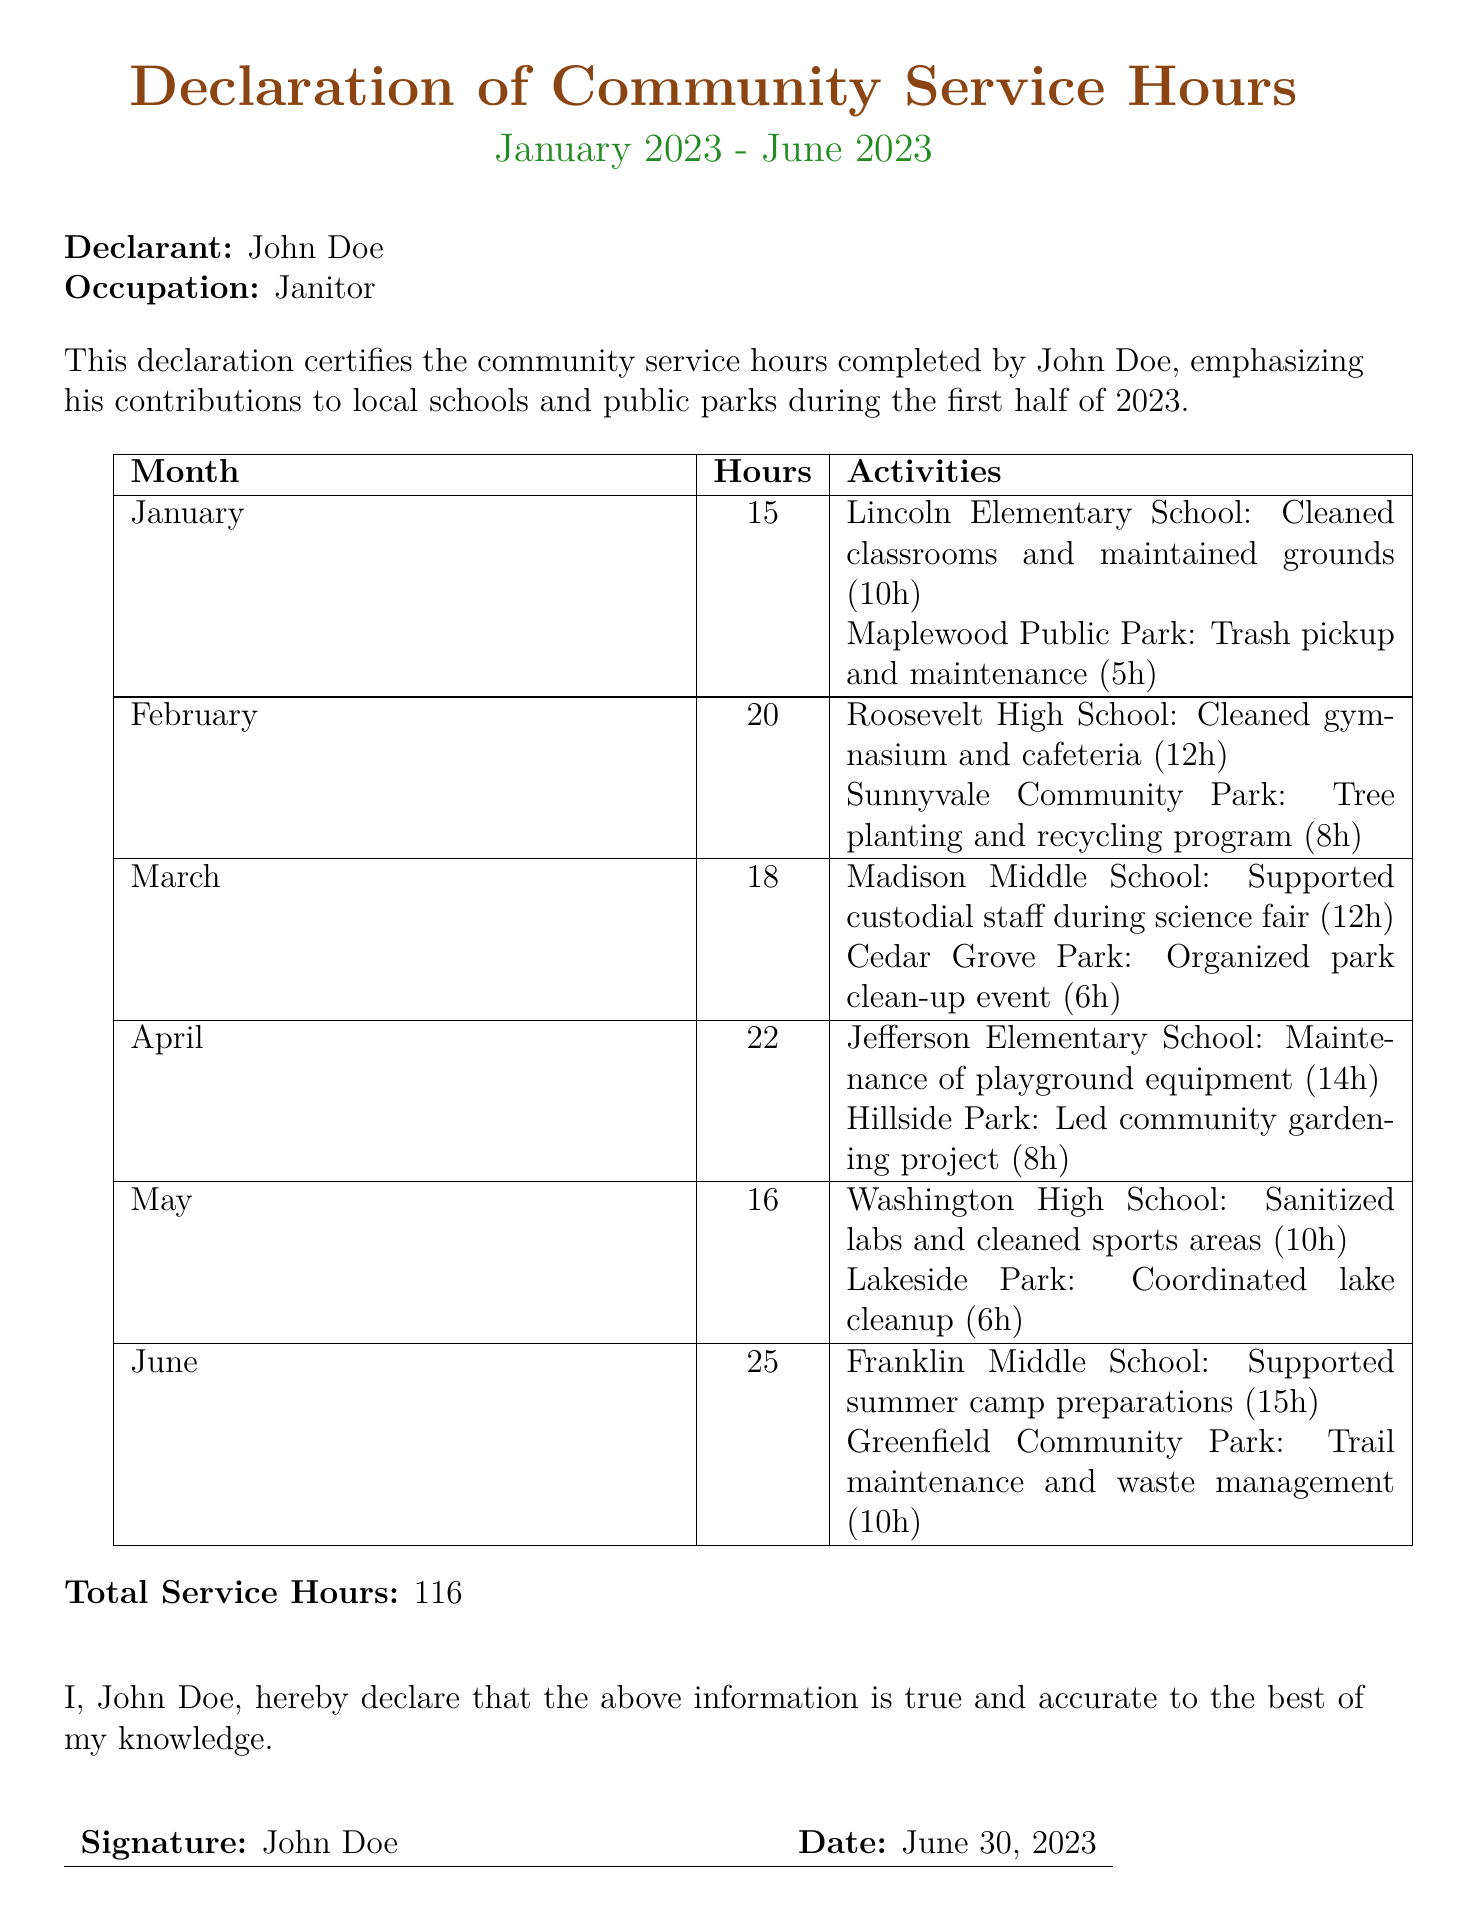What is the name of the declarant? The name of the declarant is stated at the beginning of the document.
Answer: John Doe How many hours were completed in April? The hours for each month are listed in the table and can be found under April.
Answer: 22 Which school had activities in June? The activities for June are documented in the table, specifying the school involved.
Answer: Franklin Middle School What was the total number of service hours? The total service hours is clearly stated towards the end of the document.
Answer: 116 Which park was involved in the tree planting activity? The table includes activities for February, noting the specific park related to tree planting.
Answer: Sunnyvale Community Park What kind of project was led at Hillside Park? The type of project is specified in the activities listed under April in the table.
Answer: Community gardening project On what date was the document signed? The signing date can be found next to the signature section in the declaration.
Answer: June 30, 2023 Which school was supported during the science fair? The document lists activities by month, including the specific school for March.
Answer: Madison Middle School How many hours were spent on park clean-up in March? The hours for activities in March are summarized in the table, detailing park clean-up hours.
Answer: 6 